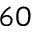<formula> <loc_0><loc_0><loc_500><loc_500>6 0</formula> 